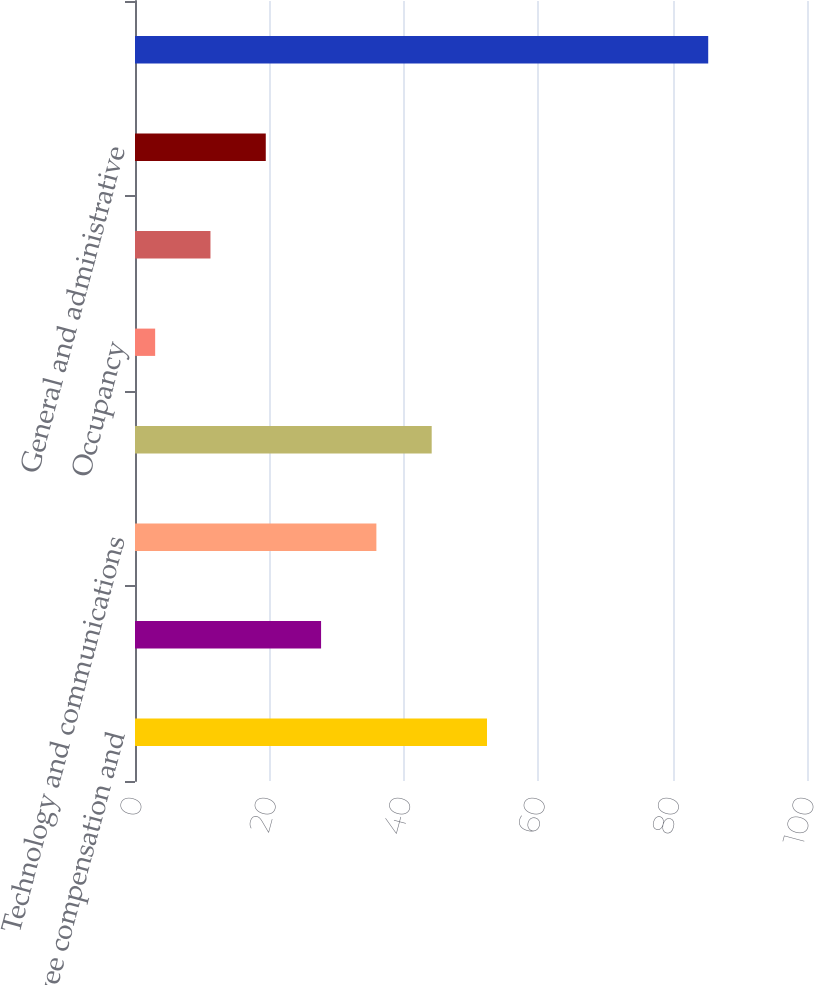<chart> <loc_0><loc_0><loc_500><loc_500><bar_chart><fcel>Employee compensation and<fcel>Depreciation and amortization<fcel>Technology and communications<fcel>Professional and consulting<fcel>Occupancy<fcel>Marketing and advertising<fcel>General and administrative<fcel>Total expenses<nl><fcel>52.38<fcel>27.69<fcel>35.92<fcel>44.15<fcel>3<fcel>11.23<fcel>19.46<fcel>85.3<nl></chart> 